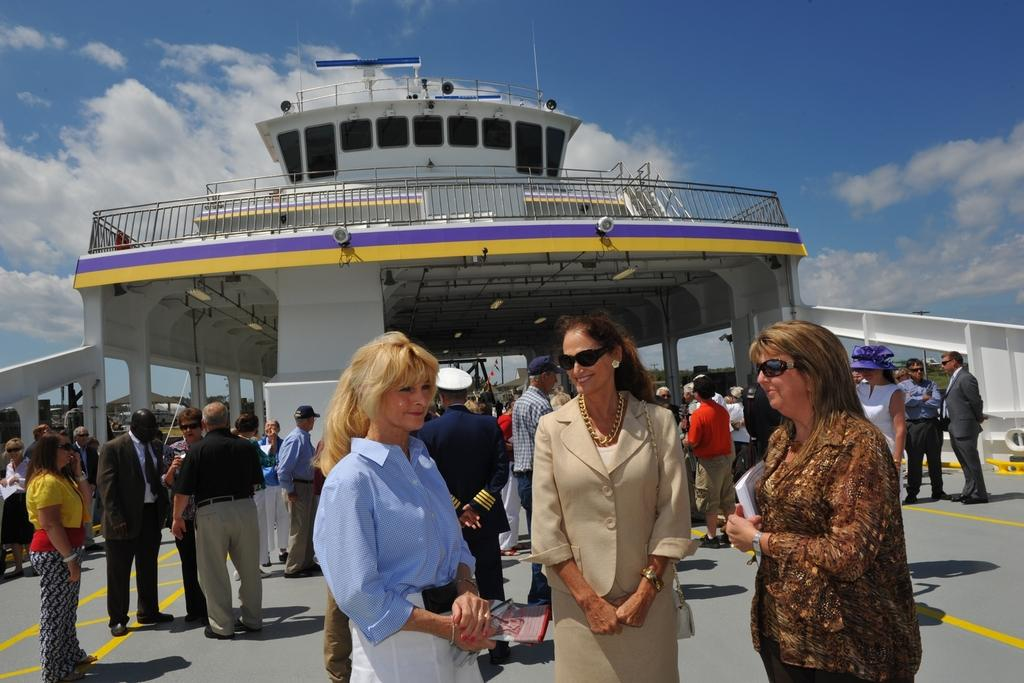How many people are in the group in the image? There is a group of people in the image, but the exact number is not specified. What accessories can be seen on some of the people in the group? Some people in the group are wearing spectacles and caps. What can be seen in the background of the image? In the background of the image, there is a shelter, metal rods, lights, and clouds. Can you describe the accessories worn by the people in the group? Some people in the group are wearing spectacles and caps. What type of salt is being used to season the food in the image? There is no food or salt present in the image; it features a group of people with accessories and a background with a shelter, metal rods, lights, and clouds. 